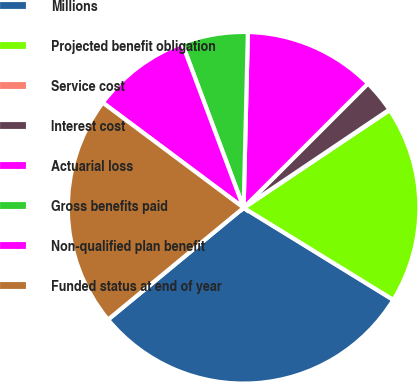Convert chart. <chart><loc_0><loc_0><loc_500><loc_500><pie_chart><fcel>Millions<fcel>Projected benefit obligation<fcel>Service cost<fcel>Interest cost<fcel>Actuarial loss<fcel>Gross benefits paid<fcel>Non-qualified plan benefit<fcel>Funded status at end of year<nl><fcel>30.24%<fcel>18.16%<fcel>0.05%<fcel>3.06%<fcel>12.12%<fcel>6.08%<fcel>9.1%<fcel>21.18%<nl></chart> 